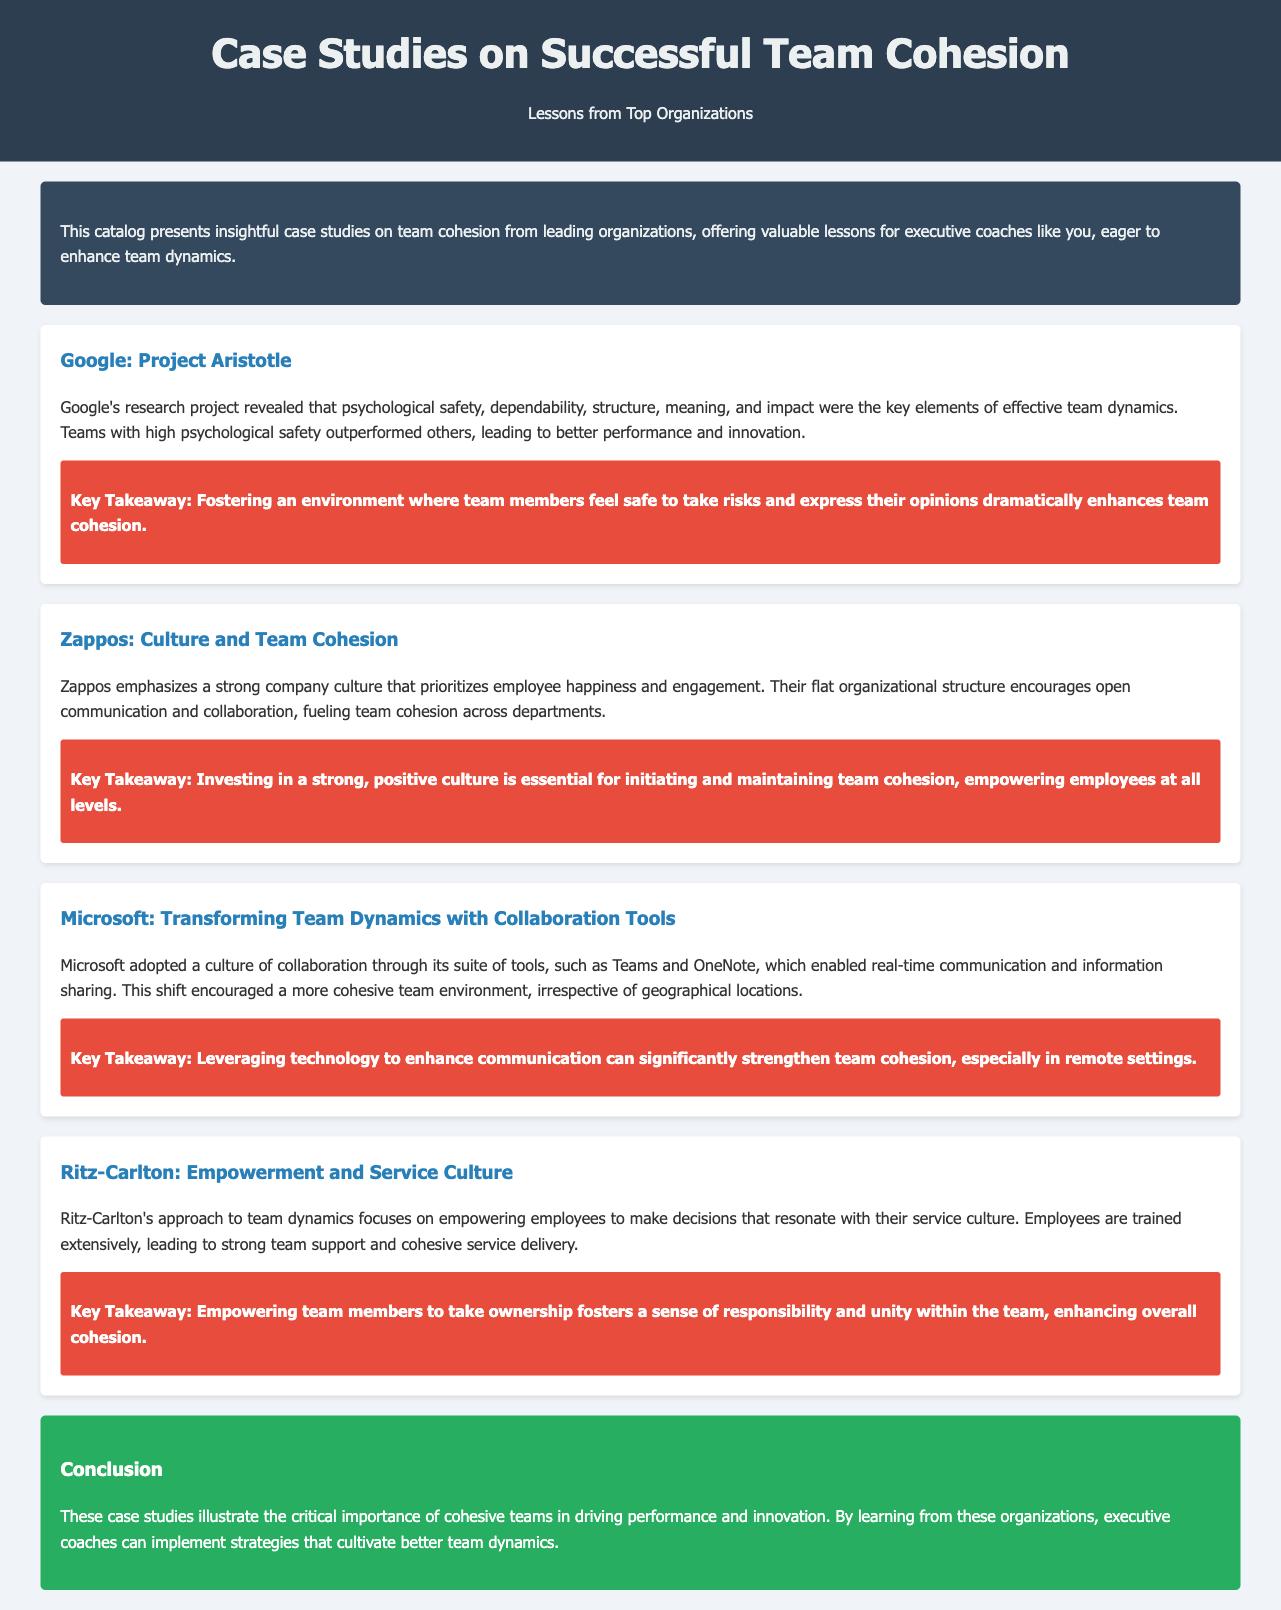What was the name of Google's research project? The document states that Google's research project is called Project Aristotle.
Answer: Project Aristotle What key element did Google find to be essential for effective team dynamics? Google identified psychological safety as a key element of effective team dynamics in their research.
Answer: Psychological safety What type of organizational structure does Zappos emphasize? According to the document, Zappos emphasizes a flat organizational structure.
Answer: Flat What technological tools did Microsoft use to enhance collaboration? The document mentions Microsoft adopted tools like Teams and OneNote to enhance collaboration.
Answer: Teams and OneNote What is the key takeaway about employee empowerment from Ritz-Carlton? The takeaway emphasizes that empowering team members fosters a sense of responsibility and unity.
Answer: Responsibility and unity How many case studies are mentioned in the document? The document outlines four distinct case studies from different organizations.
Answer: Four What is the conclusion about cohesive teams? The document concludes that cohesive teams are critical for driving performance and innovation.
Answer: Critical for driving performance and innovation What color is the background of the introduction section? The introduction section has a background color of #34495e.
Answer: #34495e 